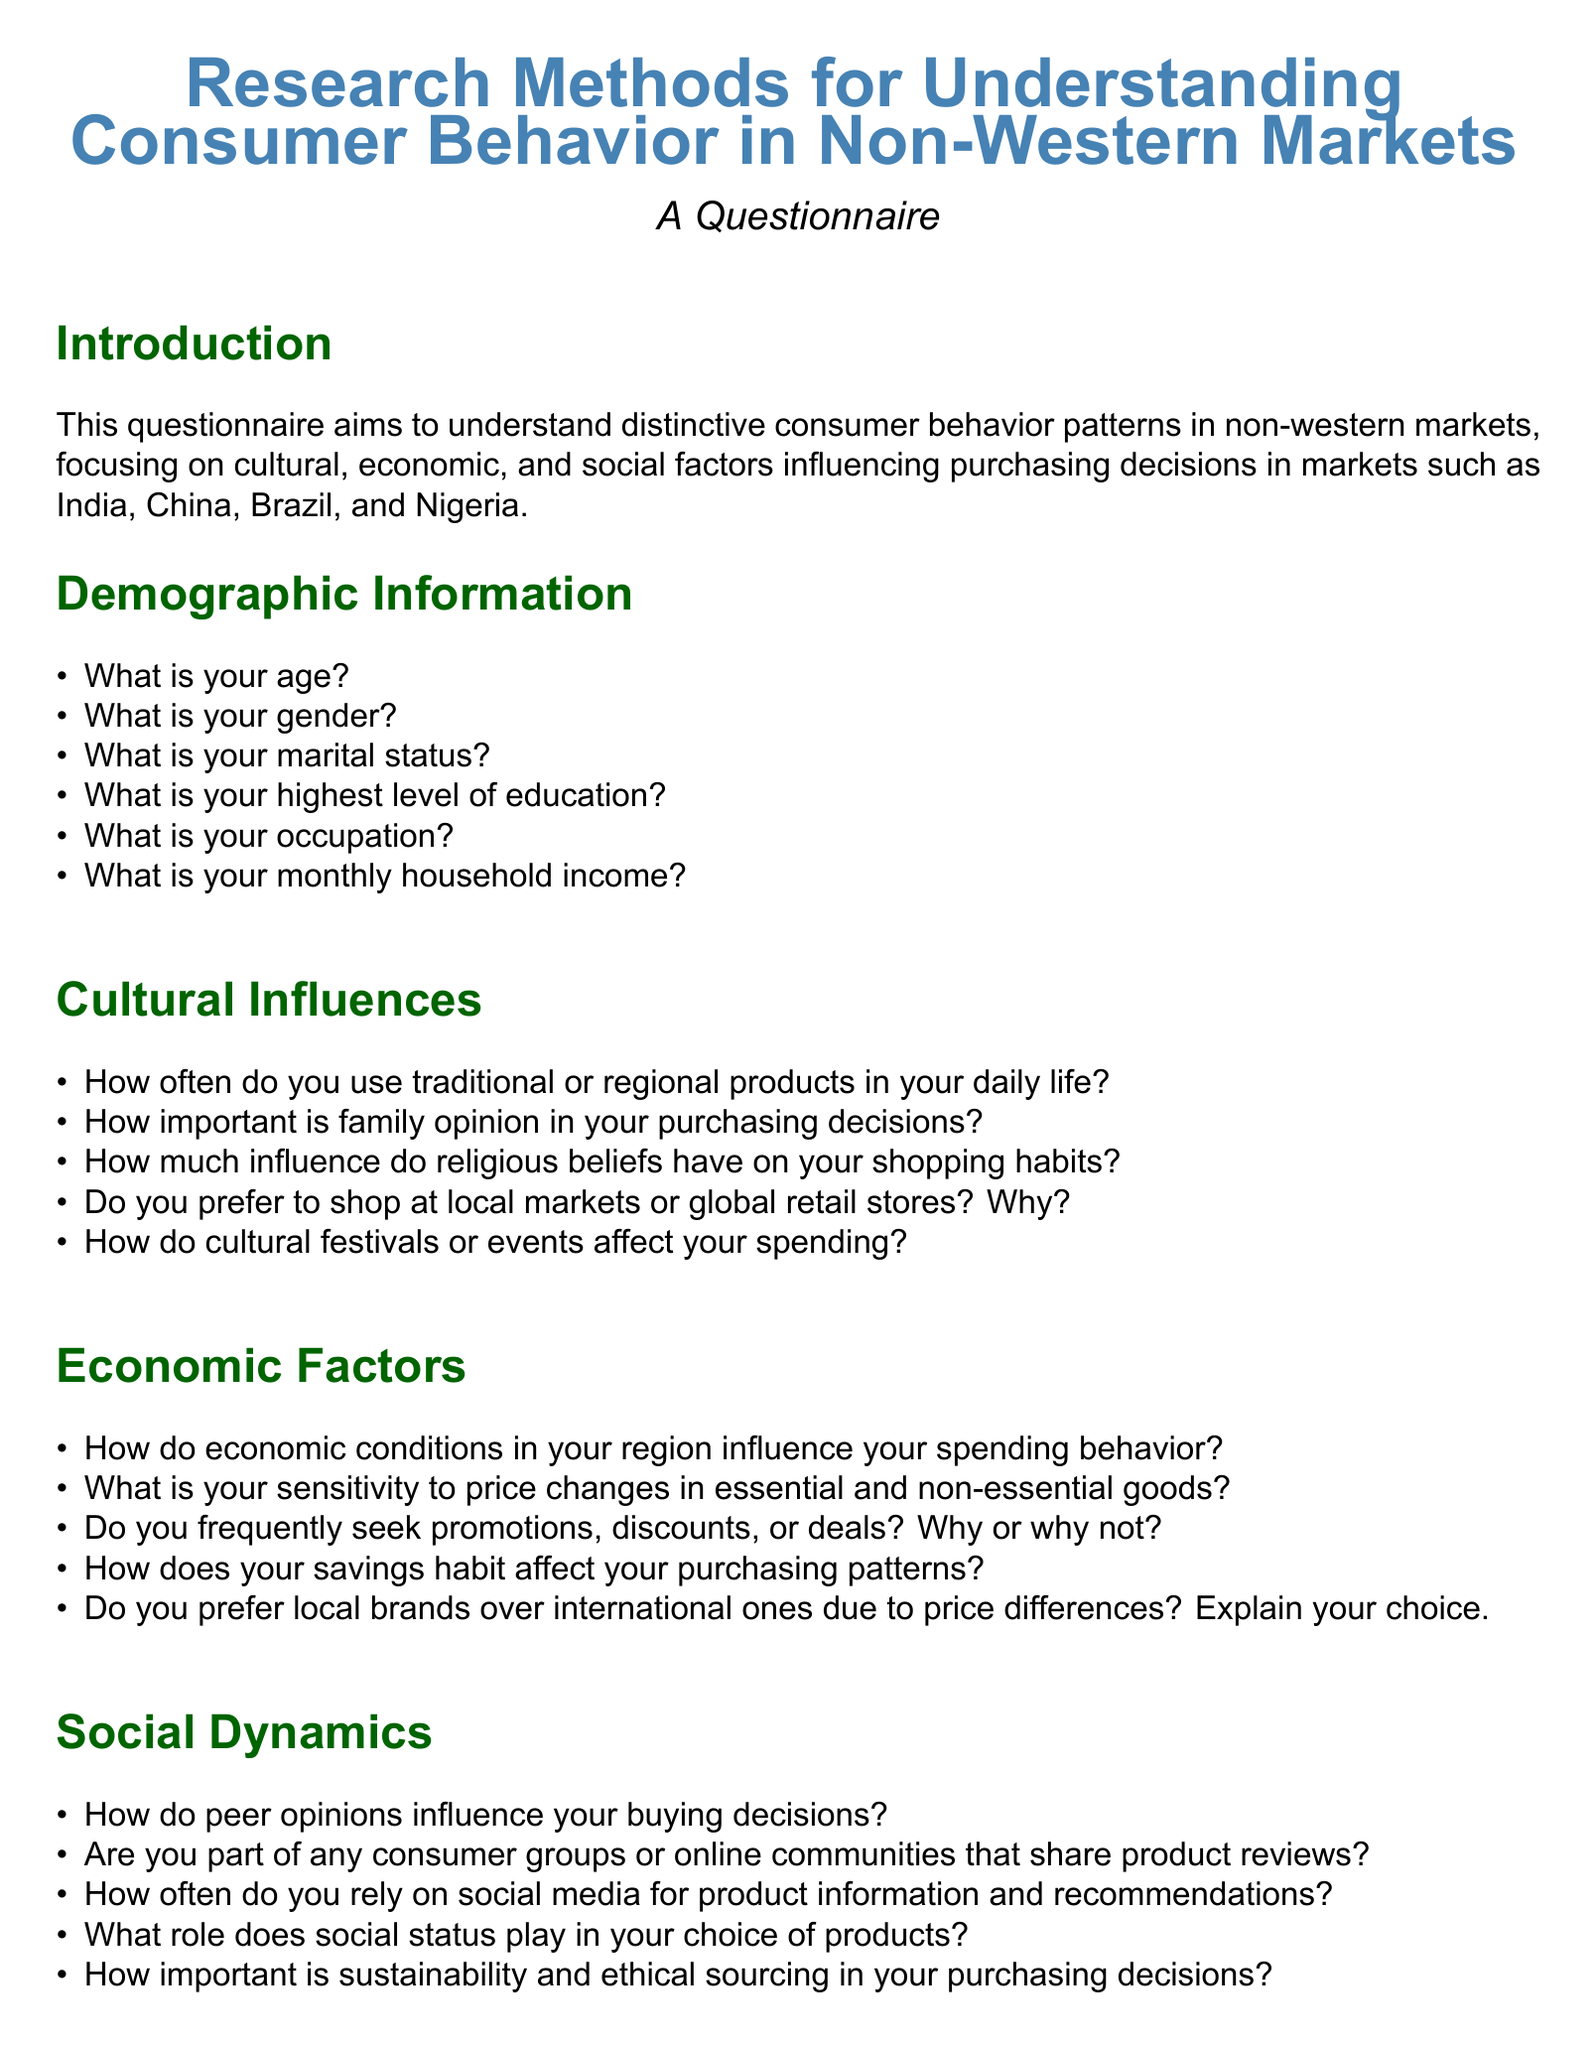What is the primary aim of the questionnaire? The questionnaire aims to understand distinctive consumer behavior patterns in non-western markets.
Answer: Understand consumer behavior patterns in non-western markets What is one of the demographic questions included in the questionnaire? The document lists various demographic questions, one of which is related to education.
Answer: Highest level of education How does the questionnaire address cultural influences? The questionnaire includes specific questions focusing on cultural factors such as family opinion in purchasing decisions.
Answer: Family opinion in purchasing decisions What is the focus of the section titled "Economic Factors"? This section examines how economics influence spending behavior and preferences.
Answer: Economic influence on spending behavior Which factor is considered in the "Social Dynamics" section? This section includes questions regarding peer influence on buying decisions and social status.
Answer: Peer opinions influence buying decisions What is one method of technology adoption mentioned in the questionnaire? The document refers to the use of specific devices for online shopping as part of the technology adoption section.
Answer: Devices for online shopping How many sections are in the questionnaire? The document is organized into several distinct sections addressing different aspects of consumer behavior.
Answer: Five sections What role does sustainability play in the purchasing decisions according to the questionnaire? A question addresses the importance of sustainability and ethical sourcing in purchasing decisions.
Answer: Sustainability and ethical sourcing What is the concluding statement of the questionnaire? The conclusion thanks participants and highlights the significance of their responses for understanding consumer behavior.
Answer: Thank you for participating in this survey 